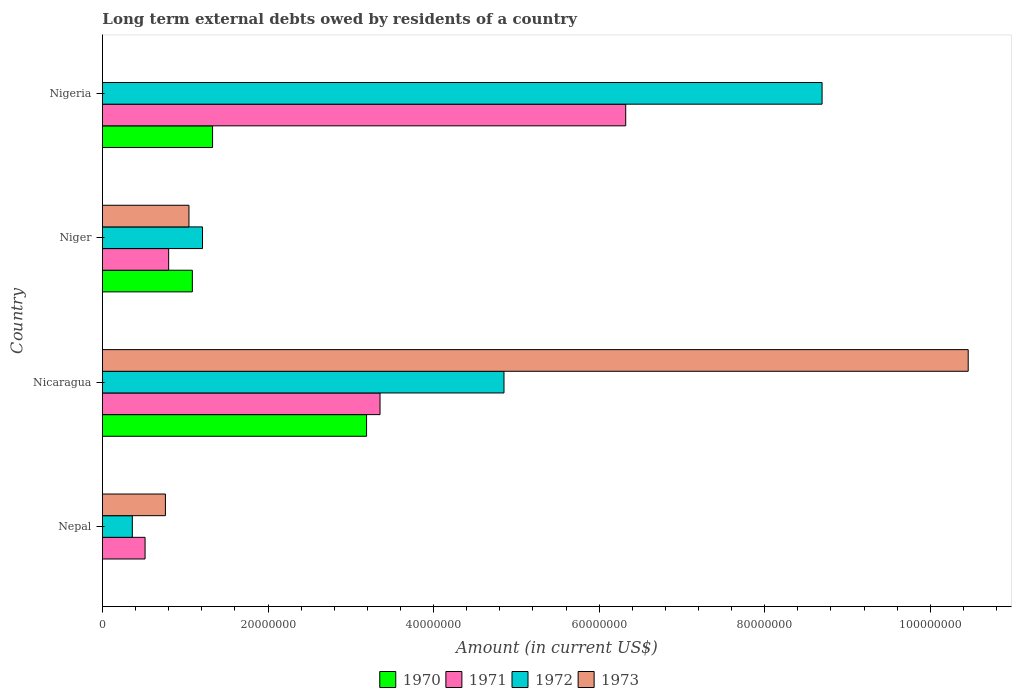How many different coloured bars are there?
Offer a terse response. 4. Are the number of bars on each tick of the Y-axis equal?
Give a very brief answer. No. What is the label of the 2nd group of bars from the top?
Your response must be concise. Niger. In how many cases, is the number of bars for a given country not equal to the number of legend labels?
Give a very brief answer. 2. What is the amount of long-term external debts owed by residents in 1971 in Niger?
Make the answer very short. 8.00e+06. Across all countries, what is the maximum amount of long-term external debts owed by residents in 1971?
Your answer should be very brief. 6.32e+07. In which country was the amount of long-term external debts owed by residents in 1971 maximum?
Your response must be concise. Nigeria. What is the total amount of long-term external debts owed by residents in 1973 in the graph?
Provide a short and direct response. 1.23e+08. What is the difference between the amount of long-term external debts owed by residents in 1970 in Niger and that in Nigeria?
Make the answer very short. -2.44e+06. What is the difference between the amount of long-term external debts owed by residents in 1973 in Niger and the amount of long-term external debts owed by residents in 1970 in Nepal?
Your response must be concise. 1.04e+07. What is the average amount of long-term external debts owed by residents in 1971 per country?
Your response must be concise. 2.75e+07. What is the difference between the amount of long-term external debts owed by residents in 1973 and amount of long-term external debts owed by residents in 1971 in Niger?
Your answer should be very brief. 2.45e+06. In how many countries, is the amount of long-term external debts owed by residents in 1972 greater than 60000000 US$?
Your answer should be compact. 1. What is the ratio of the amount of long-term external debts owed by residents in 1971 in Nicaragua to that in Nigeria?
Offer a terse response. 0.53. What is the difference between the highest and the second highest amount of long-term external debts owed by residents in 1971?
Make the answer very short. 2.97e+07. What is the difference between the highest and the lowest amount of long-term external debts owed by residents in 1971?
Your response must be concise. 5.81e+07. Is the sum of the amount of long-term external debts owed by residents in 1972 in Nepal and Niger greater than the maximum amount of long-term external debts owed by residents in 1971 across all countries?
Your response must be concise. No. Is it the case that in every country, the sum of the amount of long-term external debts owed by residents in 1973 and amount of long-term external debts owed by residents in 1970 is greater than the sum of amount of long-term external debts owed by residents in 1972 and amount of long-term external debts owed by residents in 1971?
Provide a succinct answer. No. How many bars are there?
Offer a terse response. 14. How many countries are there in the graph?
Make the answer very short. 4. Are the values on the major ticks of X-axis written in scientific E-notation?
Offer a terse response. No. Does the graph contain any zero values?
Keep it short and to the point. Yes. How are the legend labels stacked?
Keep it short and to the point. Horizontal. What is the title of the graph?
Your response must be concise. Long term external debts owed by residents of a country. Does "1963" appear as one of the legend labels in the graph?
Your response must be concise. No. What is the Amount (in current US$) in 1970 in Nepal?
Make the answer very short. 0. What is the Amount (in current US$) of 1971 in Nepal?
Keep it short and to the point. 5.15e+06. What is the Amount (in current US$) in 1972 in Nepal?
Offer a very short reply. 3.60e+06. What is the Amount (in current US$) of 1973 in Nepal?
Give a very brief answer. 7.60e+06. What is the Amount (in current US$) in 1970 in Nicaragua?
Keep it short and to the point. 3.19e+07. What is the Amount (in current US$) in 1971 in Nicaragua?
Ensure brevity in your answer.  3.35e+07. What is the Amount (in current US$) in 1972 in Nicaragua?
Give a very brief answer. 4.85e+07. What is the Amount (in current US$) of 1973 in Nicaragua?
Provide a succinct answer. 1.05e+08. What is the Amount (in current US$) of 1970 in Niger?
Your answer should be compact. 1.09e+07. What is the Amount (in current US$) in 1971 in Niger?
Provide a short and direct response. 8.00e+06. What is the Amount (in current US$) of 1972 in Niger?
Provide a succinct answer. 1.21e+07. What is the Amount (in current US$) in 1973 in Niger?
Provide a short and direct response. 1.04e+07. What is the Amount (in current US$) in 1970 in Nigeria?
Keep it short and to the point. 1.33e+07. What is the Amount (in current US$) of 1971 in Nigeria?
Offer a terse response. 6.32e+07. What is the Amount (in current US$) of 1972 in Nigeria?
Give a very brief answer. 8.69e+07. Across all countries, what is the maximum Amount (in current US$) of 1970?
Keep it short and to the point. 3.19e+07. Across all countries, what is the maximum Amount (in current US$) in 1971?
Keep it short and to the point. 6.32e+07. Across all countries, what is the maximum Amount (in current US$) of 1972?
Offer a terse response. 8.69e+07. Across all countries, what is the maximum Amount (in current US$) of 1973?
Keep it short and to the point. 1.05e+08. Across all countries, what is the minimum Amount (in current US$) of 1970?
Keep it short and to the point. 0. Across all countries, what is the minimum Amount (in current US$) in 1971?
Your answer should be very brief. 5.15e+06. Across all countries, what is the minimum Amount (in current US$) in 1972?
Your answer should be compact. 3.60e+06. Across all countries, what is the minimum Amount (in current US$) of 1973?
Your answer should be compact. 0. What is the total Amount (in current US$) in 1970 in the graph?
Your response must be concise. 5.61e+07. What is the total Amount (in current US$) in 1971 in the graph?
Ensure brevity in your answer.  1.10e+08. What is the total Amount (in current US$) in 1972 in the graph?
Your answer should be very brief. 1.51e+08. What is the total Amount (in current US$) in 1973 in the graph?
Your answer should be compact. 1.23e+08. What is the difference between the Amount (in current US$) in 1971 in Nepal and that in Nicaragua?
Offer a very short reply. -2.84e+07. What is the difference between the Amount (in current US$) in 1972 in Nepal and that in Nicaragua?
Your answer should be very brief. -4.49e+07. What is the difference between the Amount (in current US$) of 1973 in Nepal and that in Nicaragua?
Make the answer very short. -9.70e+07. What is the difference between the Amount (in current US$) in 1971 in Nepal and that in Niger?
Make the answer very short. -2.85e+06. What is the difference between the Amount (in current US$) of 1972 in Nepal and that in Niger?
Offer a very short reply. -8.48e+06. What is the difference between the Amount (in current US$) of 1973 in Nepal and that in Niger?
Make the answer very short. -2.84e+06. What is the difference between the Amount (in current US$) of 1971 in Nepal and that in Nigeria?
Your answer should be very brief. -5.81e+07. What is the difference between the Amount (in current US$) in 1972 in Nepal and that in Nigeria?
Provide a succinct answer. -8.33e+07. What is the difference between the Amount (in current US$) of 1970 in Nicaragua and that in Niger?
Offer a terse response. 2.10e+07. What is the difference between the Amount (in current US$) of 1971 in Nicaragua and that in Niger?
Offer a very short reply. 2.55e+07. What is the difference between the Amount (in current US$) in 1972 in Nicaragua and that in Niger?
Ensure brevity in your answer.  3.64e+07. What is the difference between the Amount (in current US$) in 1973 in Nicaragua and that in Niger?
Your answer should be very brief. 9.41e+07. What is the difference between the Amount (in current US$) in 1970 in Nicaragua and that in Nigeria?
Provide a succinct answer. 1.86e+07. What is the difference between the Amount (in current US$) in 1971 in Nicaragua and that in Nigeria?
Offer a very short reply. -2.97e+07. What is the difference between the Amount (in current US$) of 1972 in Nicaragua and that in Nigeria?
Provide a short and direct response. -3.84e+07. What is the difference between the Amount (in current US$) of 1970 in Niger and that in Nigeria?
Your answer should be compact. -2.44e+06. What is the difference between the Amount (in current US$) in 1971 in Niger and that in Nigeria?
Your response must be concise. -5.52e+07. What is the difference between the Amount (in current US$) in 1972 in Niger and that in Nigeria?
Your response must be concise. -7.48e+07. What is the difference between the Amount (in current US$) in 1971 in Nepal and the Amount (in current US$) in 1972 in Nicaragua?
Give a very brief answer. -4.34e+07. What is the difference between the Amount (in current US$) in 1971 in Nepal and the Amount (in current US$) in 1973 in Nicaragua?
Your response must be concise. -9.94e+07. What is the difference between the Amount (in current US$) in 1972 in Nepal and the Amount (in current US$) in 1973 in Nicaragua?
Ensure brevity in your answer.  -1.01e+08. What is the difference between the Amount (in current US$) in 1971 in Nepal and the Amount (in current US$) in 1972 in Niger?
Offer a very short reply. -6.94e+06. What is the difference between the Amount (in current US$) of 1971 in Nepal and the Amount (in current US$) of 1973 in Niger?
Your answer should be compact. -5.30e+06. What is the difference between the Amount (in current US$) in 1972 in Nepal and the Amount (in current US$) in 1973 in Niger?
Your response must be concise. -6.84e+06. What is the difference between the Amount (in current US$) of 1971 in Nepal and the Amount (in current US$) of 1972 in Nigeria?
Your response must be concise. -8.18e+07. What is the difference between the Amount (in current US$) in 1970 in Nicaragua and the Amount (in current US$) in 1971 in Niger?
Make the answer very short. 2.39e+07. What is the difference between the Amount (in current US$) in 1970 in Nicaragua and the Amount (in current US$) in 1972 in Niger?
Offer a terse response. 1.98e+07. What is the difference between the Amount (in current US$) of 1970 in Nicaragua and the Amount (in current US$) of 1973 in Niger?
Ensure brevity in your answer.  2.15e+07. What is the difference between the Amount (in current US$) in 1971 in Nicaragua and the Amount (in current US$) in 1972 in Niger?
Your response must be concise. 2.14e+07. What is the difference between the Amount (in current US$) of 1971 in Nicaragua and the Amount (in current US$) of 1973 in Niger?
Provide a short and direct response. 2.31e+07. What is the difference between the Amount (in current US$) of 1972 in Nicaragua and the Amount (in current US$) of 1973 in Niger?
Offer a very short reply. 3.81e+07. What is the difference between the Amount (in current US$) in 1970 in Nicaragua and the Amount (in current US$) in 1971 in Nigeria?
Provide a succinct answer. -3.13e+07. What is the difference between the Amount (in current US$) in 1970 in Nicaragua and the Amount (in current US$) in 1972 in Nigeria?
Your response must be concise. -5.50e+07. What is the difference between the Amount (in current US$) of 1971 in Nicaragua and the Amount (in current US$) of 1972 in Nigeria?
Give a very brief answer. -5.34e+07. What is the difference between the Amount (in current US$) of 1970 in Niger and the Amount (in current US$) of 1971 in Nigeria?
Ensure brevity in your answer.  -5.24e+07. What is the difference between the Amount (in current US$) in 1970 in Niger and the Amount (in current US$) in 1972 in Nigeria?
Offer a terse response. -7.61e+07. What is the difference between the Amount (in current US$) in 1971 in Niger and the Amount (in current US$) in 1972 in Nigeria?
Ensure brevity in your answer.  -7.89e+07. What is the average Amount (in current US$) in 1970 per country?
Offer a very short reply. 1.40e+07. What is the average Amount (in current US$) of 1971 per country?
Your answer should be compact. 2.75e+07. What is the average Amount (in current US$) in 1972 per country?
Offer a very short reply. 3.78e+07. What is the average Amount (in current US$) in 1973 per country?
Give a very brief answer. 3.07e+07. What is the difference between the Amount (in current US$) in 1971 and Amount (in current US$) in 1972 in Nepal?
Provide a short and direct response. 1.54e+06. What is the difference between the Amount (in current US$) in 1971 and Amount (in current US$) in 1973 in Nepal?
Provide a succinct answer. -2.46e+06. What is the difference between the Amount (in current US$) in 1972 and Amount (in current US$) in 1973 in Nepal?
Provide a succinct answer. -4.00e+06. What is the difference between the Amount (in current US$) of 1970 and Amount (in current US$) of 1971 in Nicaragua?
Your answer should be compact. -1.63e+06. What is the difference between the Amount (in current US$) of 1970 and Amount (in current US$) of 1972 in Nicaragua?
Provide a succinct answer. -1.66e+07. What is the difference between the Amount (in current US$) in 1970 and Amount (in current US$) in 1973 in Nicaragua?
Your response must be concise. -7.27e+07. What is the difference between the Amount (in current US$) in 1971 and Amount (in current US$) in 1972 in Nicaragua?
Give a very brief answer. -1.50e+07. What is the difference between the Amount (in current US$) of 1971 and Amount (in current US$) of 1973 in Nicaragua?
Make the answer very short. -7.10e+07. What is the difference between the Amount (in current US$) of 1972 and Amount (in current US$) of 1973 in Nicaragua?
Your answer should be very brief. -5.61e+07. What is the difference between the Amount (in current US$) in 1970 and Amount (in current US$) in 1971 in Niger?
Provide a short and direct response. 2.86e+06. What is the difference between the Amount (in current US$) of 1970 and Amount (in current US$) of 1972 in Niger?
Offer a terse response. -1.23e+06. What is the difference between the Amount (in current US$) in 1970 and Amount (in current US$) in 1973 in Niger?
Provide a short and direct response. 4.08e+05. What is the difference between the Amount (in current US$) in 1971 and Amount (in current US$) in 1972 in Niger?
Your answer should be very brief. -4.09e+06. What is the difference between the Amount (in current US$) in 1971 and Amount (in current US$) in 1973 in Niger?
Provide a succinct answer. -2.45e+06. What is the difference between the Amount (in current US$) in 1972 and Amount (in current US$) in 1973 in Niger?
Ensure brevity in your answer.  1.64e+06. What is the difference between the Amount (in current US$) of 1970 and Amount (in current US$) of 1971 in Nigeria?
Offer a very short reply. -4.99e+07. What is the difference between the Amount (in current US$) in 1970 and Amount (in current US$) in 1972 in Nigeria?
Offer a very short reply. -7.36e+07. What is the difference between the Amount (in current US$) of 1971 and Amount (in current US$) of 1972 in Nigeria?
Ensure brevity in your answer.  -2.37e+07. What is the ratio of the Amount (in current US$) of 1971 in Nepal to that in Nicaragua?
Your response must be concise. 0.15. What is the ratio of the Amount (in current US$) of 1972 in Nepal to that in Nicaragua?
Offer a terse response. 0.07. What is the ratio of the Amount (in current US$) of 1973 in Nepal to that in Nicaragua?
Provide a succinct answer. 0.07. What is the ratio of the Amount (in current US$) of 1971 in Nepal to that in Niger?
Make the answer very short. 0.64. What is the ratio of the Amount (in current US$) in 1972 in Nepal to that in Niger?
Provide a short and direct response. 0.3. What is the ratio of the Amount (in current US$) in 1973 in Nepal to that in Niger?
Provide a short and direct response. 0.73. What is the ratio of the Amount (in current US$) of 1971 in Nepal to that in Nigeria?
Your answer should be very brief. 0.08. What is the ratio of the Amount (in current US$) of 1972 in Nepal to that in Nigeria?
Keep it short and to the point. 0.04. What is the ratio of the Amount (in current US$) of 1970 in Nicaragua to that in Niger?
Keep it short and to the point. 2.94. What is the ratio of the Amount (in current US$) in 1971 in Nicaragua to that in Niger?
Ensure brevity in your answer.  4.19. What is the ratio of the Amount (in current US$) in 1972 in Nicaragua to that in Niger?
Make the answer very short. 4.01. What is the ratio of the Amount (in current US$) in 1973 in Nicaragua to that in Niger?
Provide a succinct answer. 10.01. What is the ratio of the Amount (in current US$) of 1970 in Nicaragua to that in Nigeria?
Provide a short and direct response. 2.4. What is the ratio of the Amount (in current US$) in 1971 in Nicaragua to that in Nigeria?
Provide a succinct answer. 0.53. What is the ratio of the Amount (in current US$) of 1972 in Nicaragua to that in Nigeria?
Offer a very short reply. 0.56. What is the ratio of the Amount (in current US$) of 1970 in Niger to that in Nigeria?
Provide a short and direct response. 0.82. What is the ratio of the Amount (in current US$) in 1971 in Niger to that in Nigeria?
Give a very brief answer. 0.13. What is the ratio of the Amount (in current US$) in 1972 in Niger to that in Nigeria?
Offer a very short reply. 0.14. What is the difference between the highest and the second highest Amount (in current US$) of 1970?
Provide a short and direct response. 1.86e+07. What is the difference between the highest and the second highest Amount (in current US$) in 1971?
Offer a terse response. 2.97e+07. What is the difference between the highest and the second highest Amount (in current US$) of 1972?
Ensure brevity in your answer.  3.84e+07. What is the difference between the highest and the second highest Amount (in current US$) in 1973?
Ensure brevity in your answer.  9.41e+07. What is the difference between the highest and the lowest Amount (in current US$) of 1970?
Give a very brief answer. 3.19e+07. What is the difference between the highest and the lowest Amount (in current US$) of 1971?
Provide a succinct answer. 5.81e+07. What is the difference between the highest and the lowest Amount (in current US$) in 1972?
Ensure brevity in your answer.  8.33e+07. What is the difference between the highest and the lowest Amount (in current US$) of 1973?
Provide a succinct answer. 1.05e+08. 